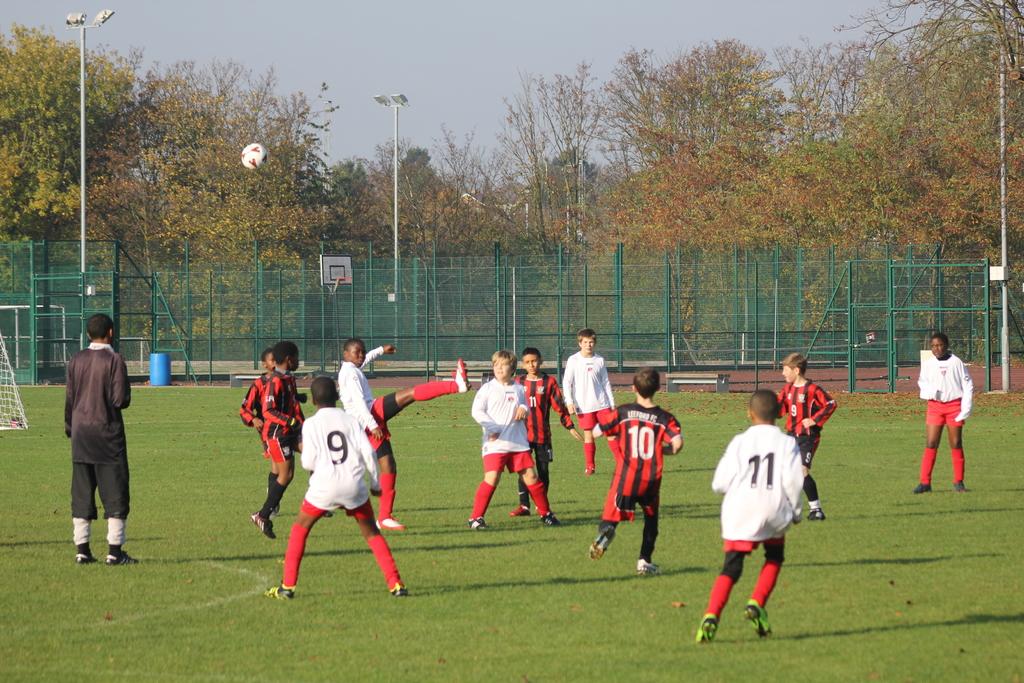What number is the kid in black and red stripes?
Keep it short and to the point. 10. What number is the person on the left?
Provide a short and direct response. 9. 